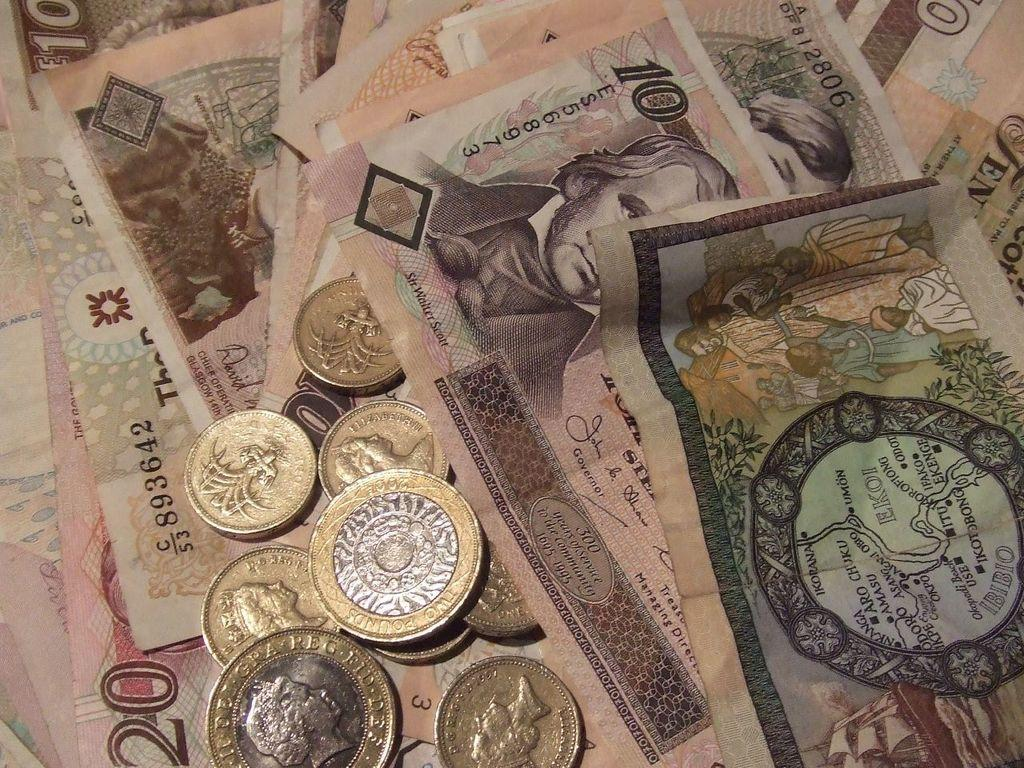<image>
Create a compact narrative representing the image presented. Coins and bills are gathered together, including a bill with serial number 893642. 